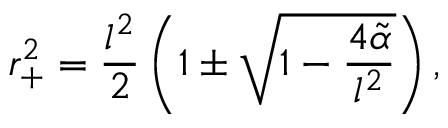<formula> <loc_0><loc_0><loc_500><loc_500>r _ { + } ^ { 2 } = \frac { l ^ { 2 } } { 2 } \left ( 1 \pm \sqrt { 1 - \frac { 4 \tilde { \alpha } } { l ^ { 2 } } } \right ) ,</formula> 